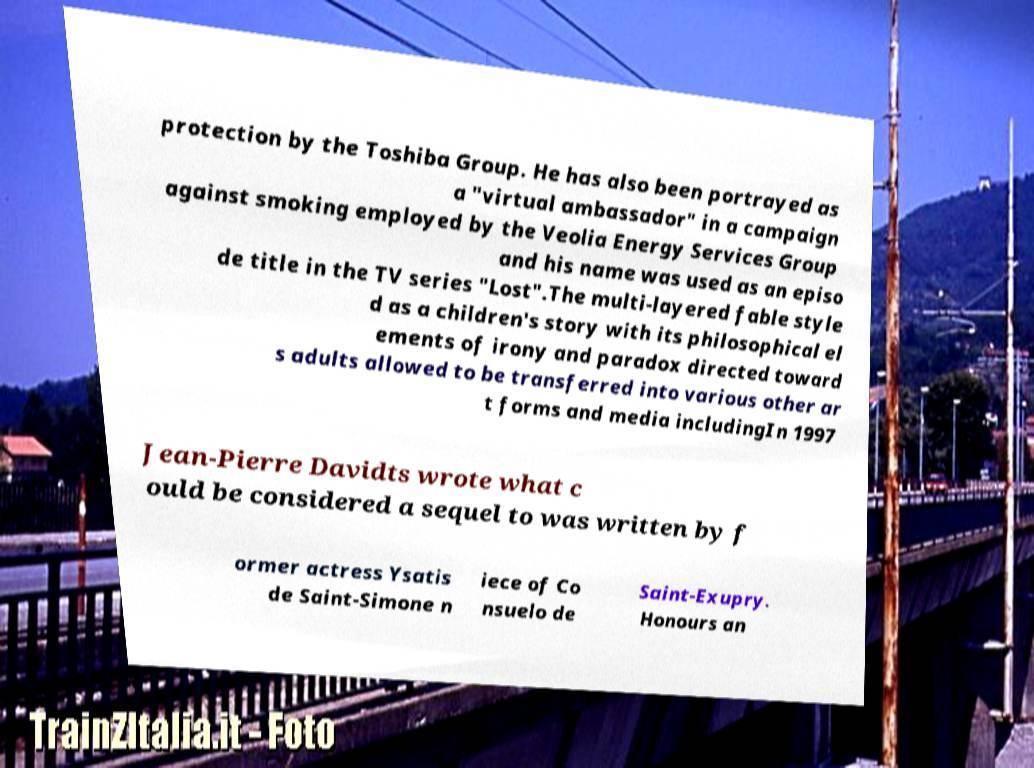Can you read and provide the text displayed in the image?This photo seems to have some interesting text. Can you extract and type it out for me? protection by the Toshiba Group. He has also been portrayed as a "virtual ambassador" in a campaign against smoking employed by the Veolia Energy Services Group and his name was used as an episo de title in the TV series "Lost".The multi-layered fable style d as a children's story with its philosophical el ements of irony and paradox directed toward s adults allowed to be transferred into various other ar t forms and media includingIn 1997 Jean-Pierre Davidts wrote what c ould be considered a sequel to was written by f ormer actress Ysatis de Saint-Simone n iece of Co nsuelo de Saint-Exupry. Honours an 